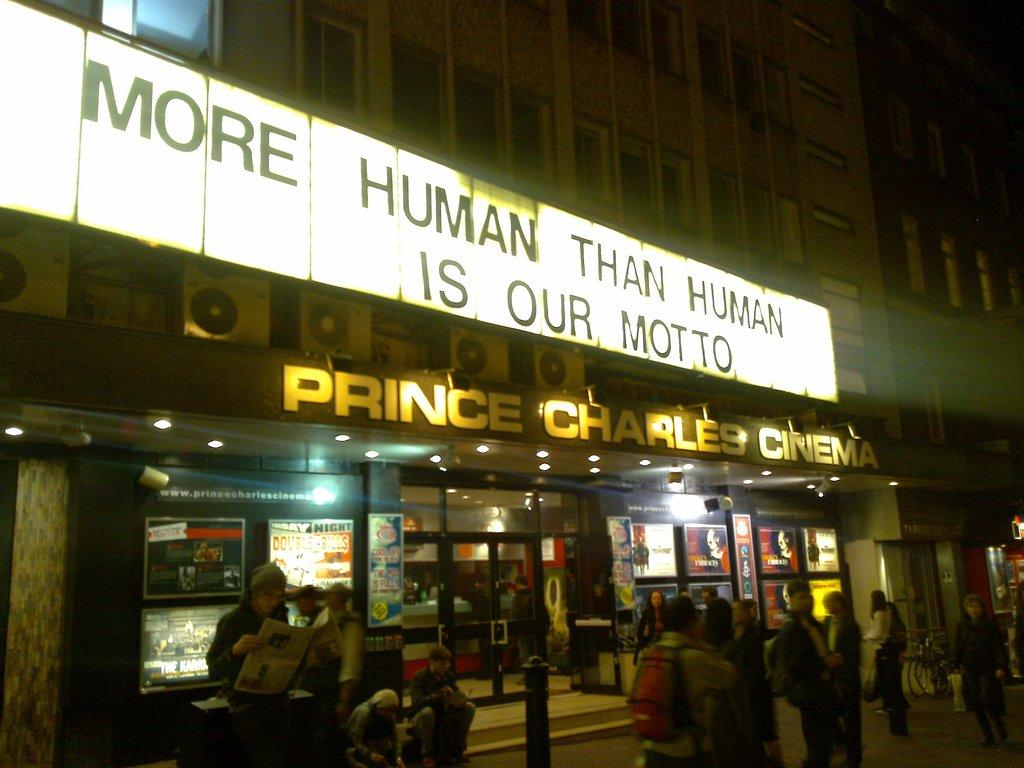<image>
Summarize the visual content of the image. People standing outdoors in front of the Prince Charles Cinema 